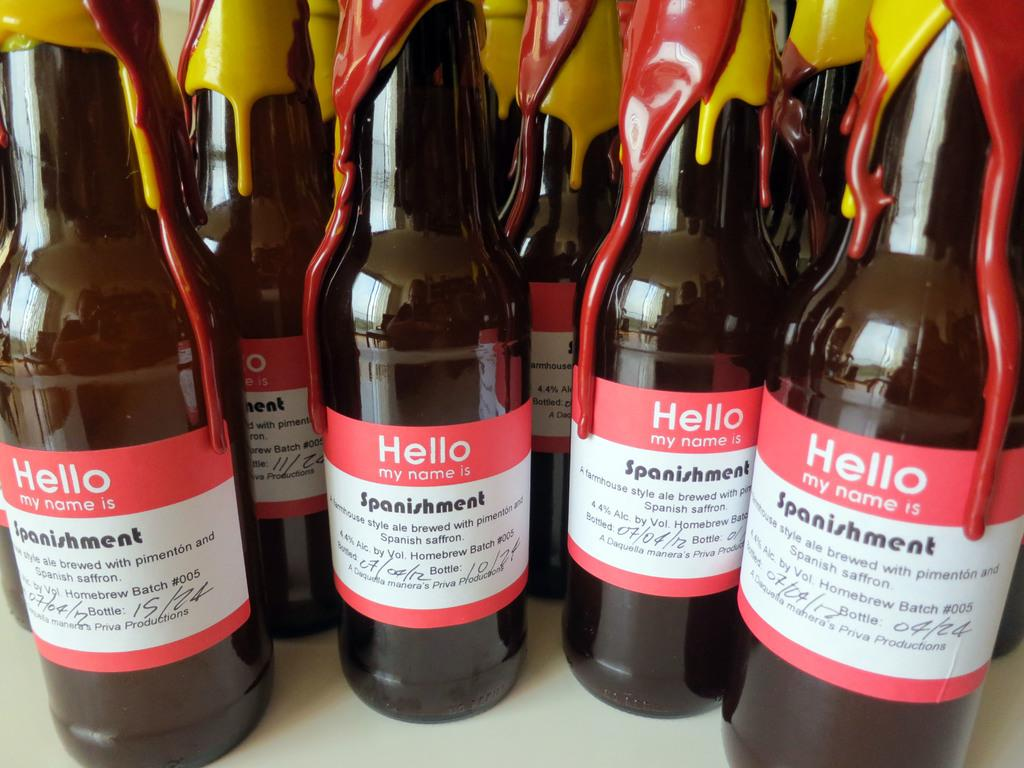<image>
Share a concise interpretation of the image provided. Some bottles with the word hello written on them. 